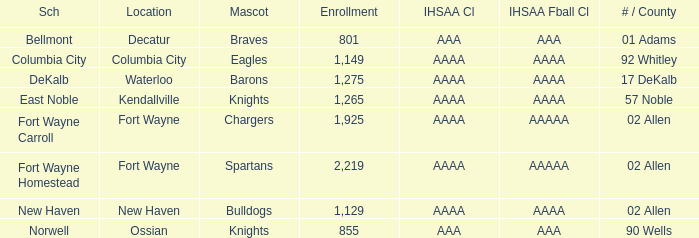What school has a mascot of the spartans with an AAAA IHSAA class and more than 1,275 enrolled? Fort Wayne Homestead. 